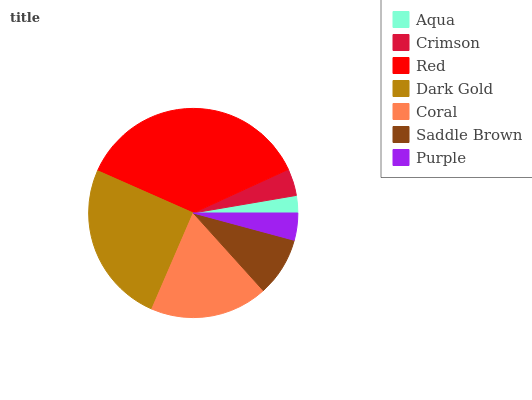Is Aqua the minimum?
Answer yes or no. Yes. Is Red the maximum?
Answer yes or no. Yes. Is Crimson the minimum?
Answer yes or no. No. Is Crimson the maximum?
Answer yes or no. No. Is Crimson greater than Aqua?
Answer yes or no. Yes. Is Aqua less than Crimson?
Answer yes or no. Yes. Is Aqua greater than Crimson?
Answer yes or no. No. Is Crimson less than Aqua?
Answer yes or no. No. Is Saddle Brown the high median?
Answer yes or no. Yes. Is Saddle Brown the low median?
Answer yes or no. Yes. Is Purple the high median?
Answer yes or no. No. Is Aqua the low median?
Answer yes or no. No. 